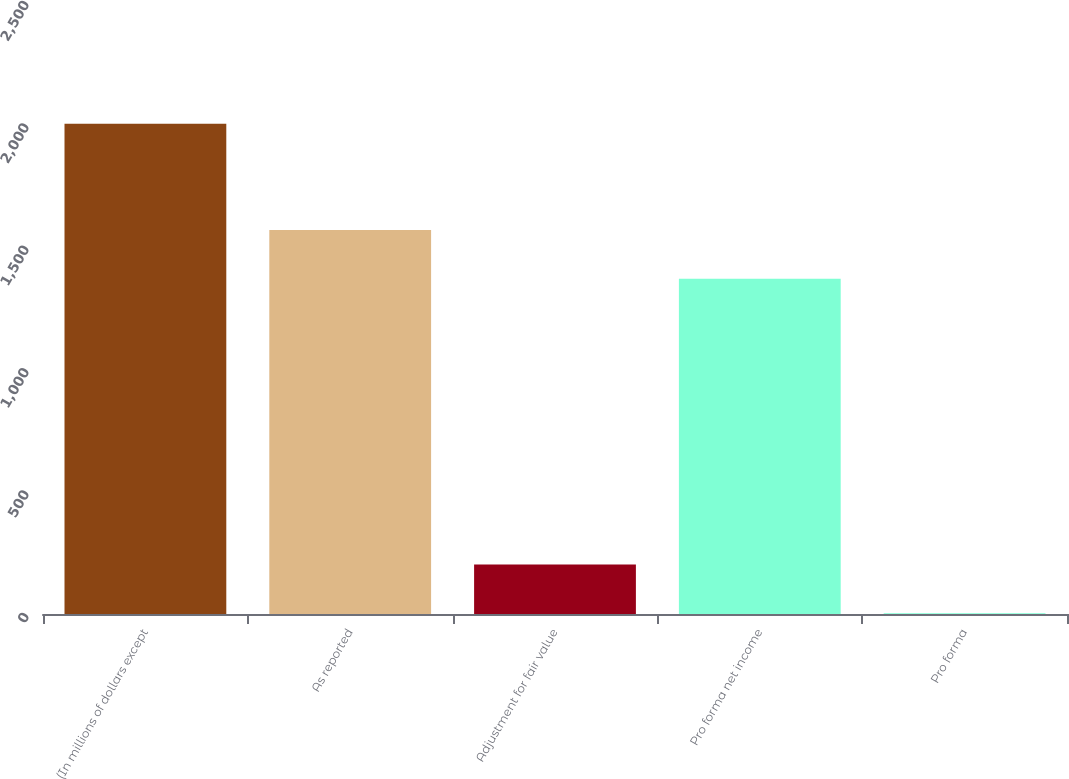Convert chart to OTSL. <chart><loc_0><loc_0><loc_500><loc_500><bar_chart><fcel>(In millions of dollars except<fcel>As reported<fcel>Adjustment for fair value<fcel>Pro forma net income<fcel>Pro forma<nl><fcel>2003<fcel>1569.04<fcel>202.61<fcel>1369<fcel>2.57<nl></chart> 